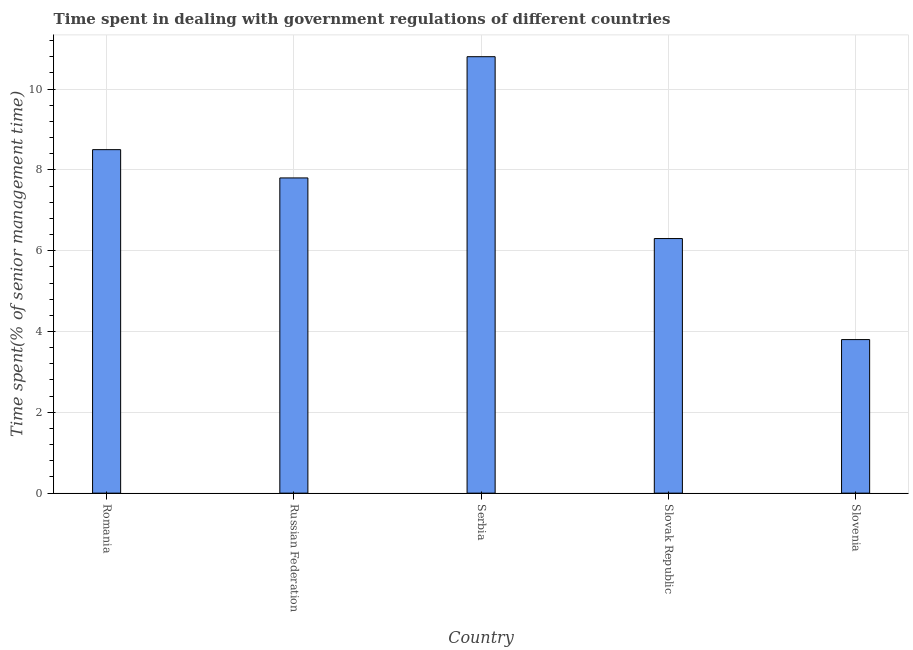Does the graph contain any zero values?
Ensure brevity in your answer.  No. What is the title of the graph?
Your answer should be very brief. Time spent in dealing with government regulations of different countries. What is the label or title of the Y-axis?
Your answer should be very brief. Time spent(% of senior management time). What is the time spent in dealing with government regulations in Slovak Republic?
Your answer should be compact. 6.3. In which country was the time spent in dealing with government regulations maximum?
Give a very brief answer. Serbia. In which country was the time spent in dealing with government regulations minimum?
Your response must be concise. Slovenia. What is the sum of the time spent in dealing with government regulations?
Your answer should be very brief. 37.2. What is the average time spent in dealing with government regulations per country?
Your response must be concise. 7.44. What is the median time spent in dealing with government regulations?
Offer a very short reply. 7.8. What is the ratio of the time spent in dealing with government regulations in Serbia to that in Slovak Republic?
Offer a terse response. 1.71. Is the time spent in dealing with government regulations in Slovak Republic less than that in Slovenia?
Ensure brevity in your answer.  No. What is the difference between the highest and the second highest time spent in dealing with government regulations?
Your answer should be compact. 2.3. What is the difference between the highest and the lowest time spent in dealing with government regulations?
Your answer should be compact. 7. Are the values on the major ticks of Y-axis written in scientific E-notation?
Provide a succinct answer. No. What is the Time spent(% of senior management time) of Slovenia?
Your answer should be compact. 3.8. What is the difference between the Time spent(% of senior management time) in Serbia and Slovak Republic?
Keep it short and to the point. 4.5. What is the difference between the Time spent(% of senior management time) in Serbia and Slovenia?
Your response must be concise. 7. What is the ratio of the Time spent(% of senior management time) in Romania to that in Russian Federation?
Keep it short and to the point. 1.09. What is the ratio of the Time spent(% of senior management time) in Romania to that in Serbia?
Provide a succinct answer. 0.79. What is the ratio of the Time spent(% of senior management time) in Romania to that in Slovak Republic?
Give a very brief answer. 1.35. What is the ratio of the Time spent(% of senior management time) in Romania to that in Slovenia?
Ensure brevity in your answer.  2.24. What is the ratio of the Time spent(% of senior management time) in Russian Federation to that in Serbia?
Provide a short and direct response. 0.72. What is the ratio of the Time spent(% of senior management time) in Russian Federation to that in Slovak Republic?
Your response must be concise. 1.24. What is the ratio of the Time spent(% of senior management time) in Russian Federation to that in Slovenia?
Make the answer very short. 2.05. What is the ratio of the Time spent(% of senior management time) in Serbia to that in Slovak Republic?
Make the answer very short. 1.71. What is the ratio of the Time spent(% of senior management time) in Serbia to that in Slovenia?
Your answer should be compact. 2.84. What is the ratio of the Time spent(% of senior management time) in Slovak Republic to that in Slovenia?
Provide a short and direct response. 1.66. 